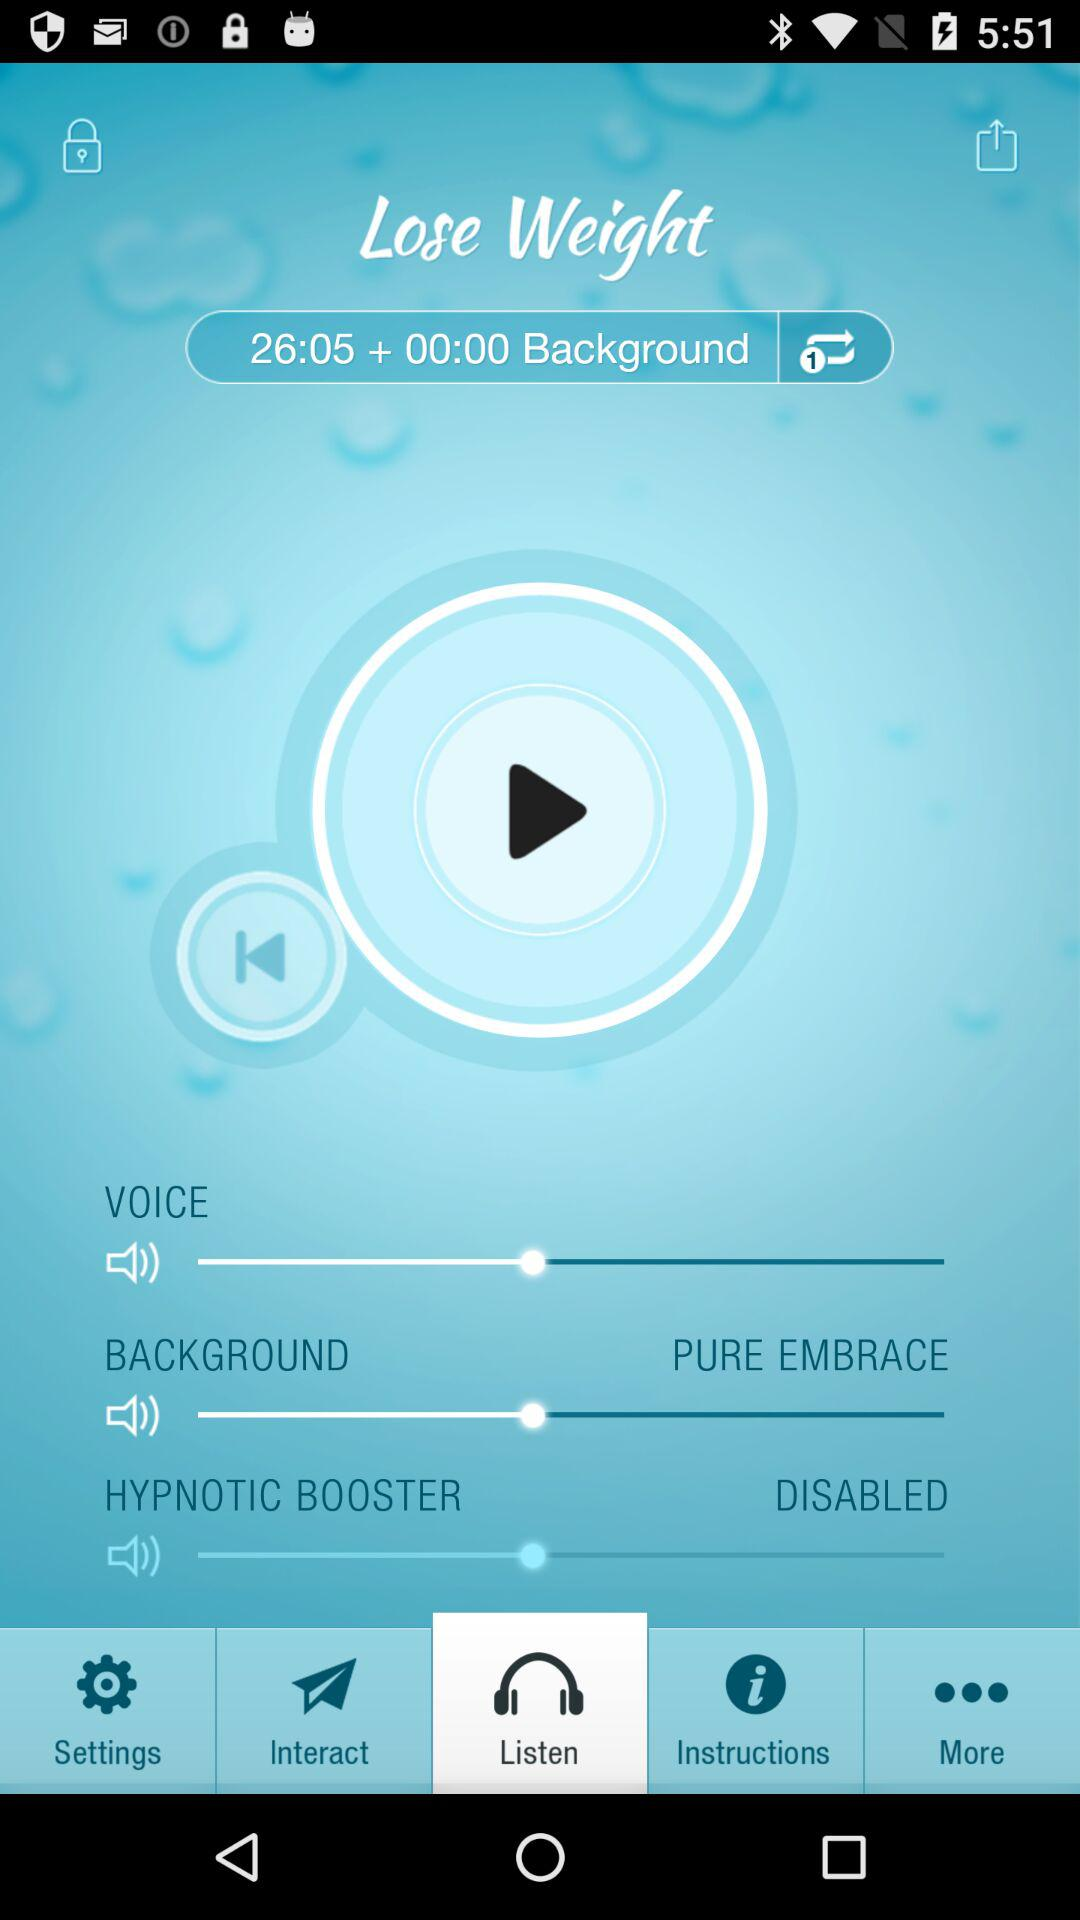Which tab is currently selected? The currently selected tab is "Listen". 